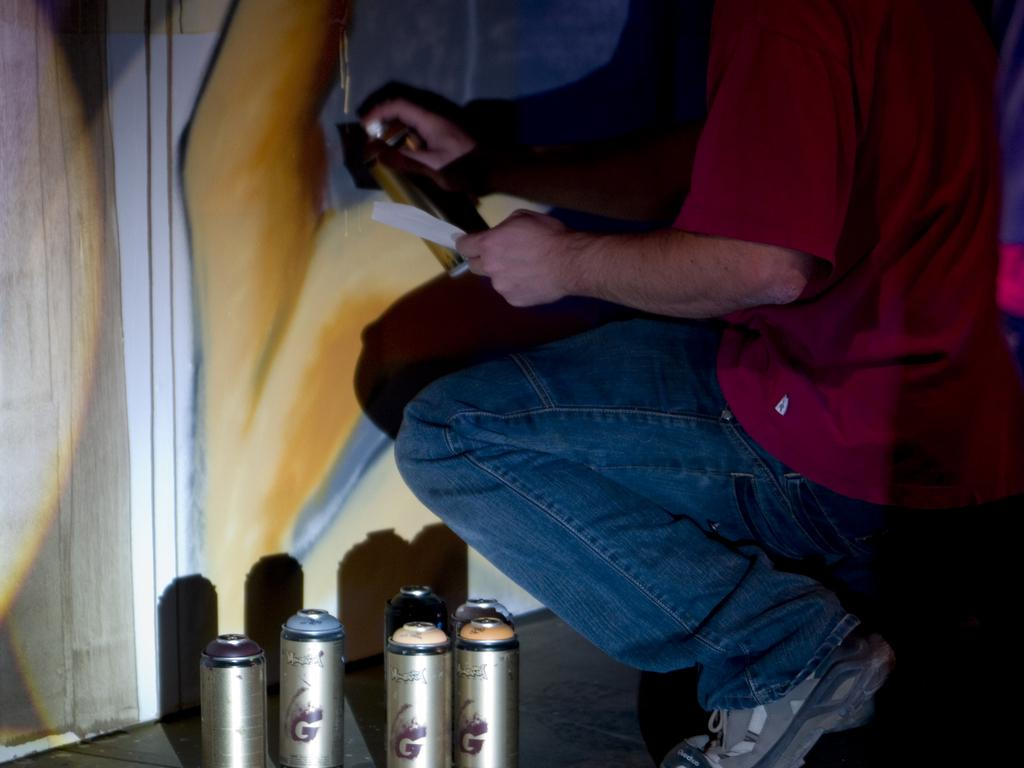What is the main subject of the image? There is a person standing in the image. What is the person holding in their hands? The person is holding something in their hands, but the specific object is not mentioned in the facts. What else can be seen in the image besides the person? There are bottles visible in the image. What is visible in the background of the image? There is a wall in the background of the image. What type of plantation can be seen in the image? There is no plantation present in the image; it features a person standing, bottles, and a wall in the background. What thoughts does the person have in the image? The thoughts of the person cannot be determined from the image, as we cannot see inside their mind. 